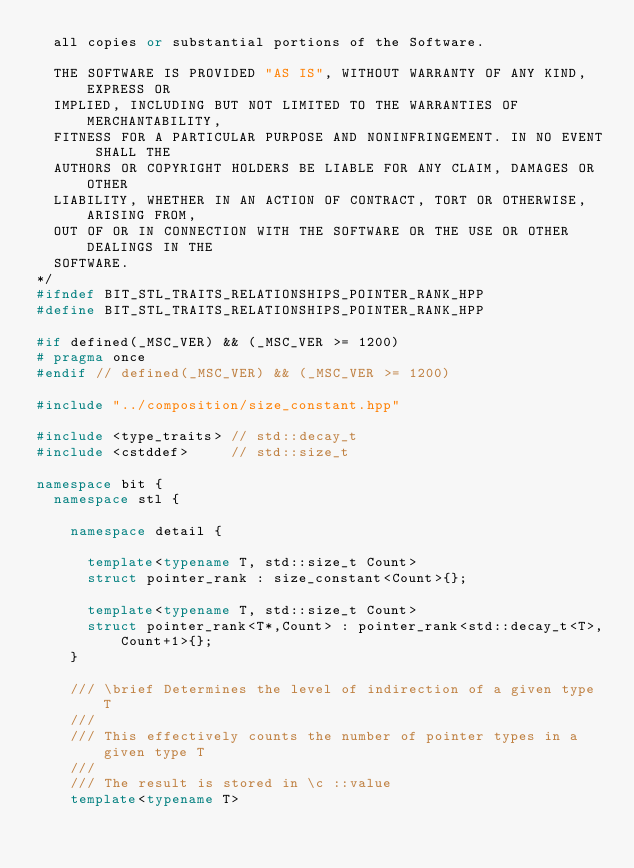<code> <loc_0><loc_0><loc_500><loc_500><_C++_>  all copies or substantial portions of the Software.

  THE SOFTWARE IS PROVIDED "AS IS", WITHOUT WARRANTY OF ANY KIND, EXPRESS OR
  IMPLIED, INCLUDING BUT NOT LIMITED TO THE WARRANTIES OF MERCHANTABILITY,
  FITNESS FOR A PARTICULAR PURPOSE AND NONINFRINGEMENT. IN NO EVENT SHALL THE
  AUTHORS OR COPYRIGHT HOLDERS BE LIABLE FOR ANY CLAIM, DAMAGES OR OTHER
  LIABILITY, WHETHER IN AN ACTION OF CONTRACT, TORT OR OTHERWISE, ARISING FROM,
  OUT OF OR IN CONNECTION WITH THE SOFTWARE OR THE USE OR OTHER DEALINGS IN THE
  SOFTWARE.
*/
#ifndef BIT_STL_TRAITS_RELATIONSHIPS_POINTER_RANK_HPP
#define BIT_STL_TRAITS_RELATIONSHIPS_POINTER_RANK_HPP

#if defined(_MSC_VER) && (_MSC_VER >= 1200)
# pragma once
#endif // defined(_MSC_VER) && (_MSC_VER >= 1200)

#include "../composition/size_constant.hpp"

#include <type_traits> // std::decay_t
#include <cstddef>     // std::size_t

namespace bit {
  namespace stl {

    namespace detail {

      template<typename T, std::size_t Count>
      struct pointer_rank : size_constant<Count>{};

      template<typename T, std::size_t Count>
      struct pointer_rank<T*,Count> : pointer_rank<std::decay_t<T>,Count+1>{};
    }

    /// \brief Determines the level of indirection of a given type T
    ///
    /// This effectively counts the number of pointer types in a given type T
    ///
    /// The result is stored in \c ::value
    template<typename T></code> 